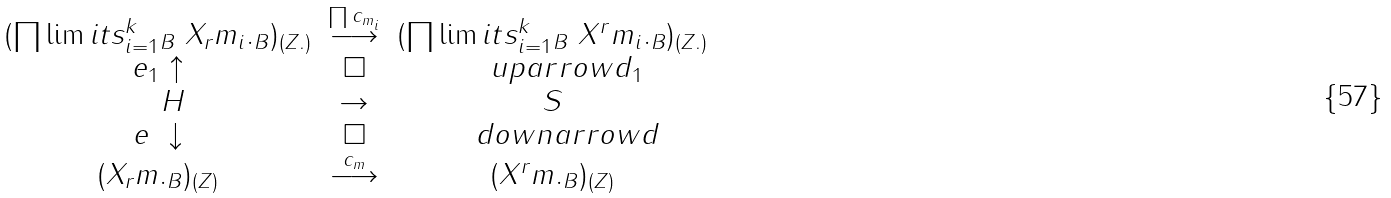Convert formula to latex. <formula><loc_0><loc_0><loc_500><loc_500>\begin{matrix} ( \prod \lim i t s _ { i = 1 } ^ { k } { _ { B } } \ X _ { r } m _ { i } . _ { B } ) _ { ( Z . ) } & \stackrel { \prod c _ { m _ { i } } } { \longrightarrow } & ( \prod \lim i t s _ { i = 1 } ^ { k } { _ { B } } \ X ^ { r } m _ { i } . _ { B } ) _ { ( Z . ) } \\ e _ { 1 } \uparrow & \square & \quad u p a r r o w d _ { 1 } \\ \quad H & \to & S \\ e \ \downarrow & \square & \quad d o w n a r r o w d \\ ( X _ { r } m . _ { B } ) _ { ( Z ) } & \stackrel { c _ { m } } { \longrightarrow } & ( X ^ { r } m . _ { B } ) _ { ( Z ) } \end{matrix}</formula> 